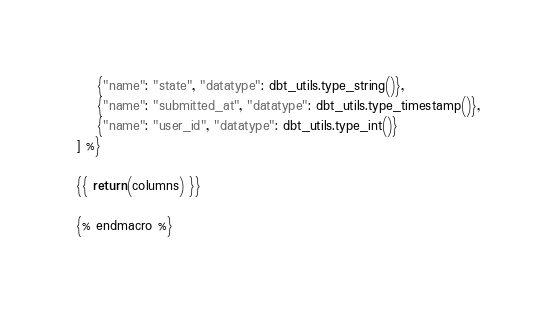<code> <loc_0><loc_0><loc_500><loc_500><_SQL_>    {"name": "state", "datatype": dbt_utils.type_string()},
    {"name": "submitted_at", "datatype": dbt_utils.type_timestamp()},
    {"name": "user_id", "datatype": dbt_utils.type_int()}
] %}

{{ return(columns) }}

{% endmacro %}
</code> 